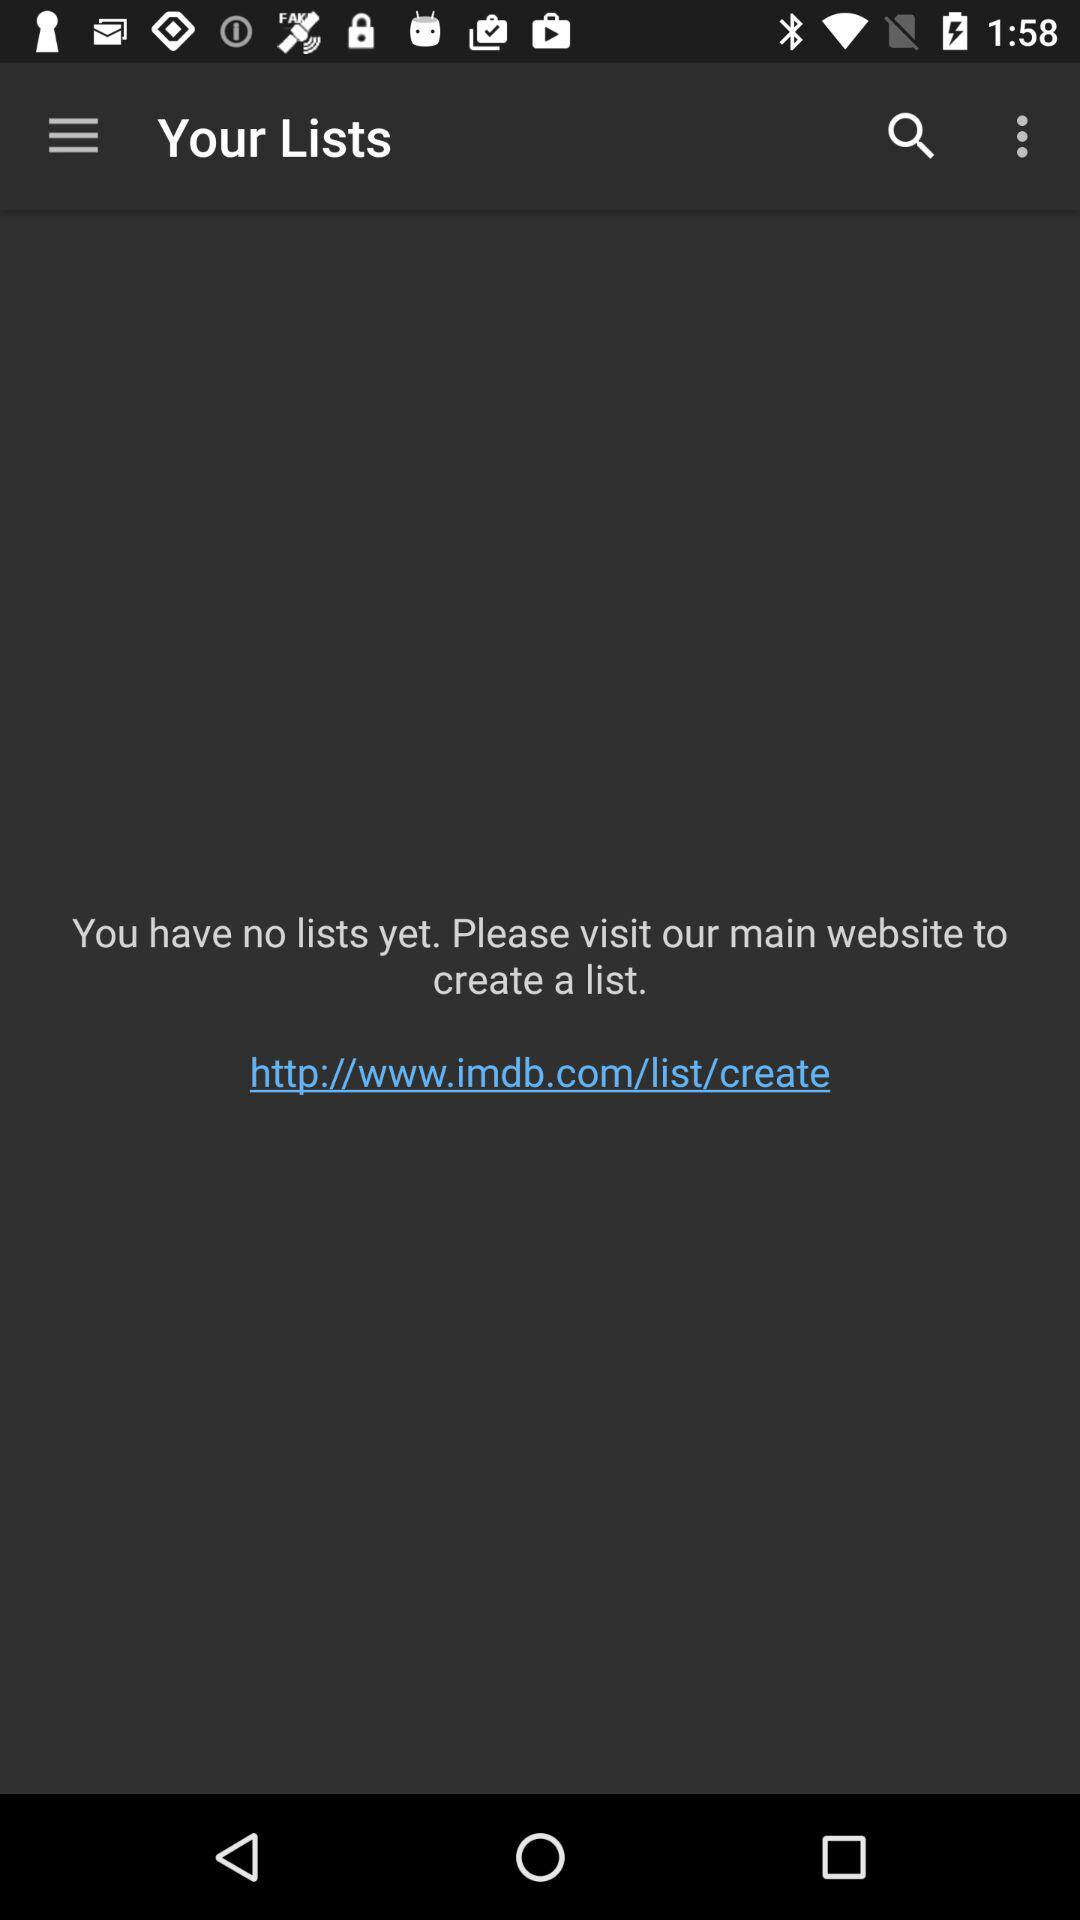Are there any lists? There is no list. 